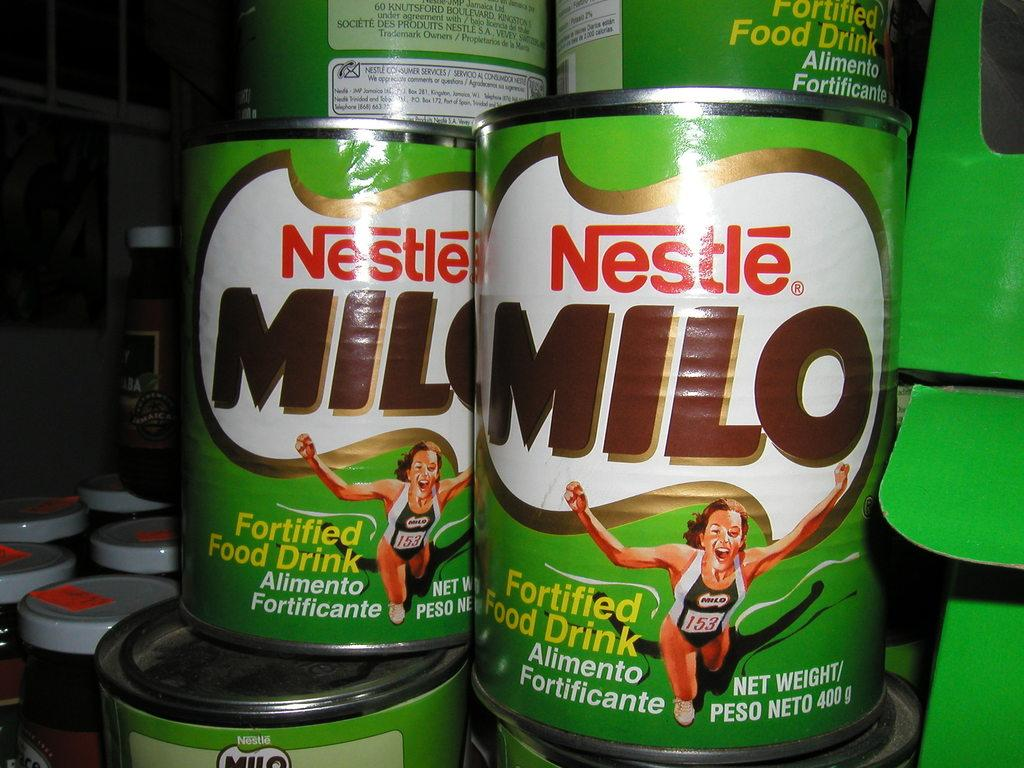<image>
Write a terse but informative summary of the picture. Several cans of Nestle Milo fortified food drink are stacked together, on top of one another. 